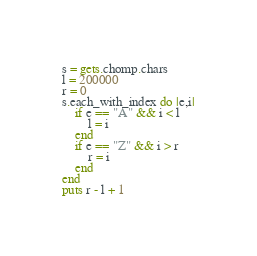Convert code to text. <code><loc_0><loc_0><loc_500><loc_500><_Ruby_>s = gets.chomp.chars
l = 200000
r = 0
s.each_with_index do |e,i|
	if e == "A" && i < l
		l = i
	end
	if e == "Z" && i > r
		r = i
	end
end
puts r - l + 1
</code> 